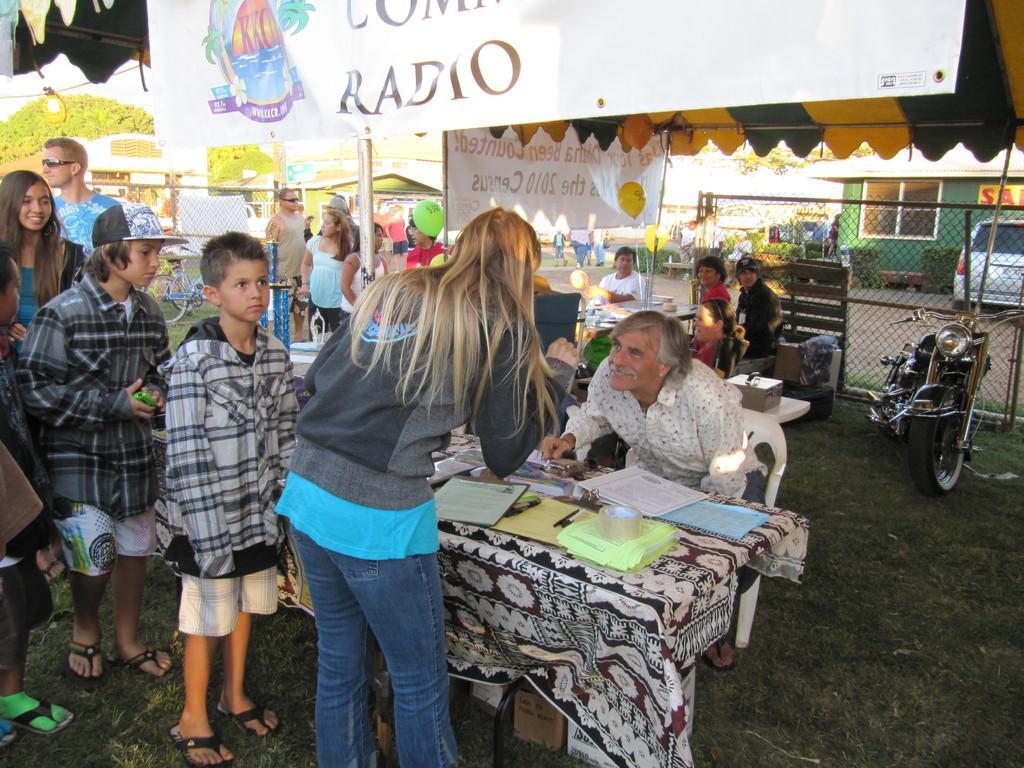In one or two sentences, can you explain what this image depicts? There are many people standing in queue. A person is sitting on a chair. There is a table. On the table there is a cloth, paper, insulation tape, books, writing pads and many other items. In the ground there are grass. In the background there is a motor cycle, some people are sitting, house, car, fencing, also there is banner, balloons. On top there is a banner. 